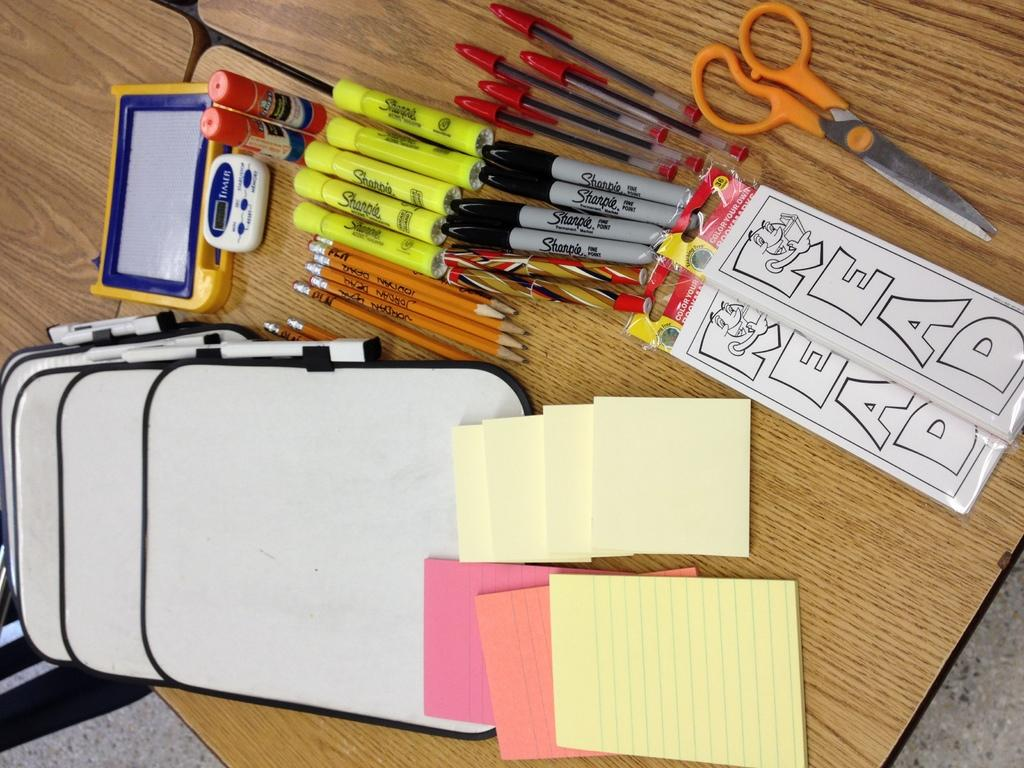<image>
Summarize the visual content of the image. a pair of scissors next to paper that says read 